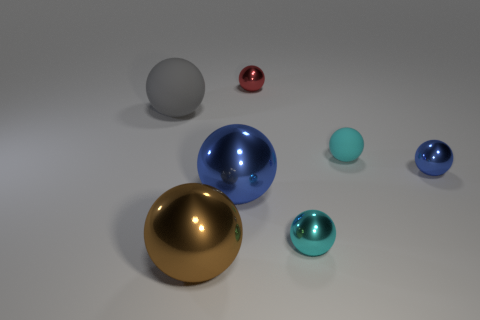How many things are large shiny spheres behind the large brown metallic sphere or objects to the left of the tiny red metallic thing?
Keep it short and to the point. 3. What number of cyan shiny objects are in front of the cyan thing behind the blue object behind the big blue ball?
Ensure brevity in your answer.  1. There is a brown metal thing that is on the right side of the large gray rubber thing; what is its size?
Provide a succinct answer. Large. How many red objects are the same size as the cyan shiny thing?
Your answer should be very brief. 1. There is a gray ball; does it have the same size as the blue metal thing that is on the right side of the large blue shiny object?
Make the answer very short. No. How many things are either small cyan metal objects or tiny yellow objects?
Make the answer very short. 1. How many small metal balls are the same color as the small rubber object?
Offer a terse response. 1. There is a brown object that is the same size as the gray ball; what shape is it?
Your answer should be compact. Sphere. Is there a small shiny object that has the same shape as the big blue object?
Offer a very short reply. Yes. What number of cyan things are the same material as the large brown object?
Provide a succinct answer. 1. 